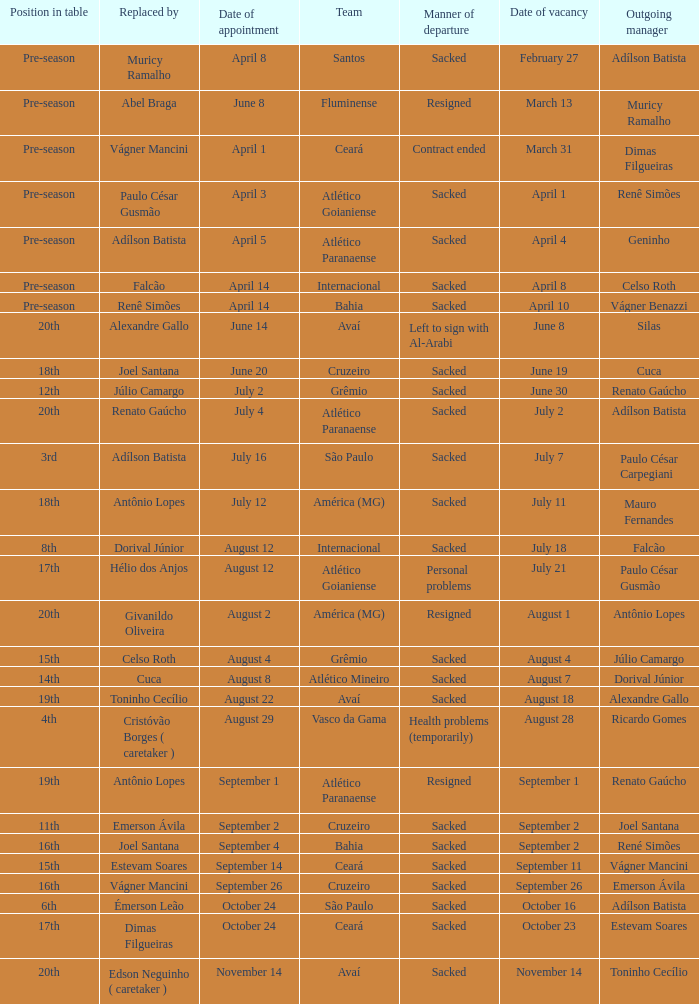Why did Geninho leave as manager? Sacked. 